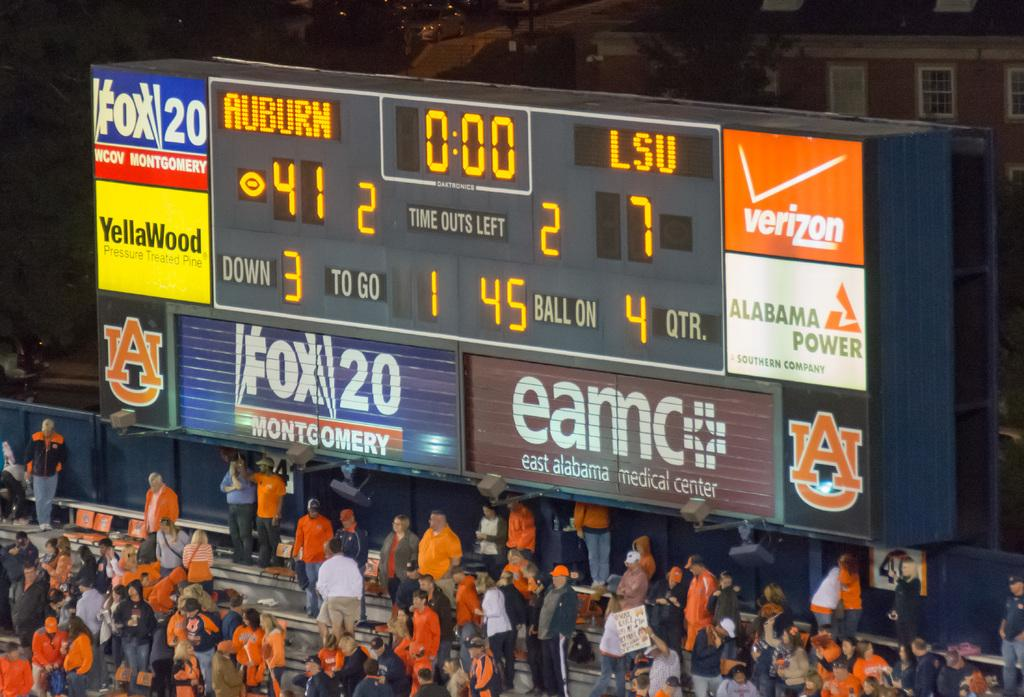<image>
Offer a succinct explanation of the picture presented. Auburn is leading LSU in the game 41 points to 7 points. 